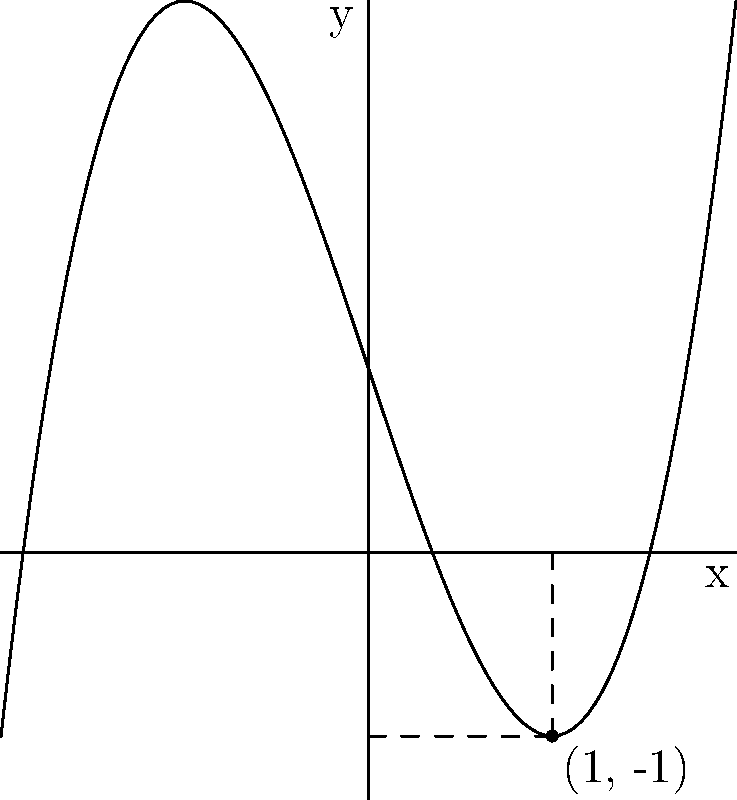As a pigment enthusiast exploring the relationship between pigment concentration and saturation, you've modeled a curve representing pigment saturation using the function $f(x) = x^3 - 3x + 1$, where $x$ represents the pigment concentration. Find the equation of the tangent line to this curve at the point where $x = 1$. To find the equation of the tangent line, we need to follow these steps:

1) The general equation of a tangent line is $y - y_1 = m(x - x_1)$, where $(x_1, y_1)$ is the point of tangency and $m$ is the slope of the tangent line.

2) We know $x_1 = 1$. Let's find $y_1$:
   $y_1 = f(1) = 1^3 - 3(1) + 1 = 1 - 3 + 1 = -1$
   So, the point of tangency is $(1, -1)$.

3) To find the slope $m$, we need to calculate $f'(x)$ and then evaluate it at $x = 1$:
   $f'(x) = 3x^2 - 3$
   $f'(1) = 3(1)^2 - 3 = 3 - 3 = 0$

4) Now we have all the components to form the equation:
   $y - (-1) = 0(x - 1)$

5) Simplify:
   $y + 1 = 0$
   $y = -1$

Therefore, the equation of the tangent line is $y = -1$.
Answer: $y = -1$ 